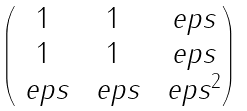Convert formula to latex. <formula><loc_0><loc_0><loc_500><loc_500>\begin{pmatrix} 1 & 1 & \ e p s \\ 1 & 1 & \ e p s \\ \ e p s & \ e p s & \ e p s ^ { 2 } \end{pmatrix}</formula> 